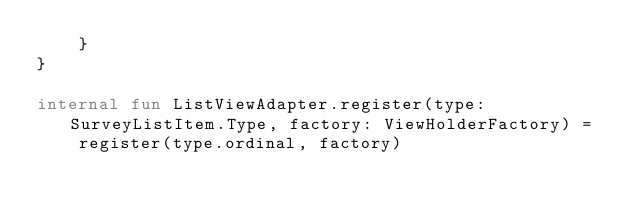Convert code to text. <code><loc_0><loc_0><loc_500><loc_500><_Kotlin_>    }
}

internal fun ListViewAdapter.register(type: SurveyListItem.Type, factory: ViewHolderFactory) =
    register(type.ordinal, factory)
</code> 